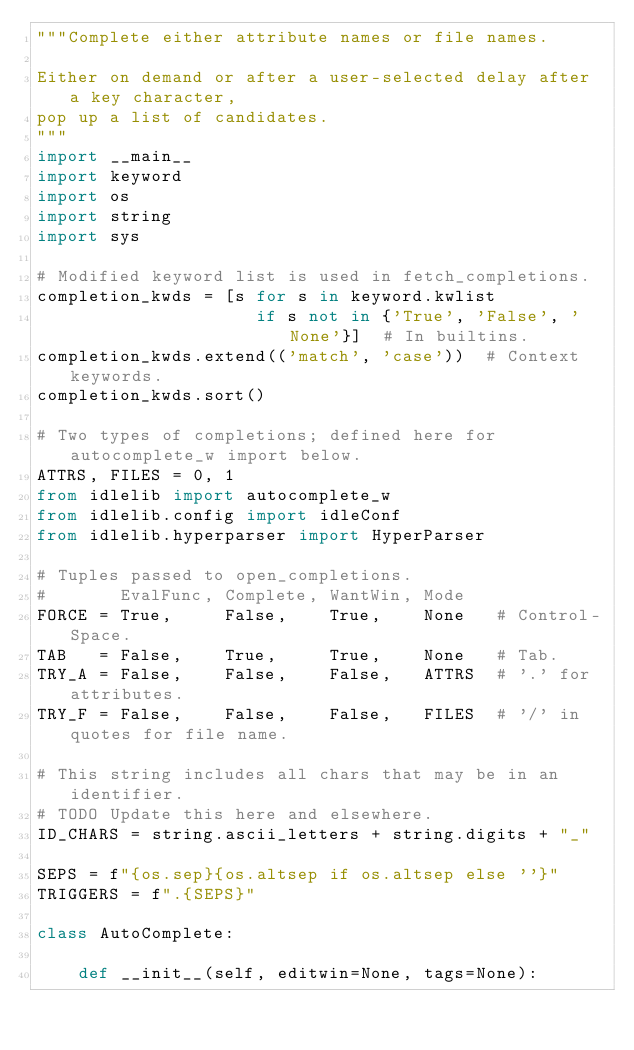Convert code to text. <code><loc_0><loc_0><loc_500><loc_500><_Python_>"""Complete either attribute names or file names.

Either on demand or after a user-selected delay after a key character,
pop up a list of candidates.
"""
import __main__
import keyword
import os
import string
import sys

# Modified keyword list is used in fetch_completions.
completion_kwds = [s for s in keyword.kwlist
                     if s not in {'True', 'False', 'None'}]  # In builtins.
completion_kwds.extend(('match', 'case'))  # Context keywords.
completion_kwds.sort()

# Two types of completions; defined here for autocomplete_w import below.
ATTRS, FILES = 0, 1
from idlelib import autocomplete_w
from idlelib.config import idleConf
from idlelib.hyperparser import HyperParser

# Tuples passed to open_completions.
#       EvalFunc, Complete, WantWin, Mode
FORCE = True,     False,    True,    None   # Control-Space.
TAB   = False,    True,     True,    None   # Tab.
TRY_A = False,    False,    False,   ATTRS  # '.' for attributes.
TRY_F = False,    False,    False,   FILES  # '/' in quotes for file name.

# This string includes all chars that may be in an identifier.
# TODO Update this here and elsewhere.
ID_CHARS = string.ascii_letters + string.digits + "_"

SEPS = f"{os.sep}{os.altsep if os.altsep else ''}"
TRIGGERS = f".{SEPS}"

class AutoComplete:

    def __init__(self, editwin=None, tags=None):</code> 